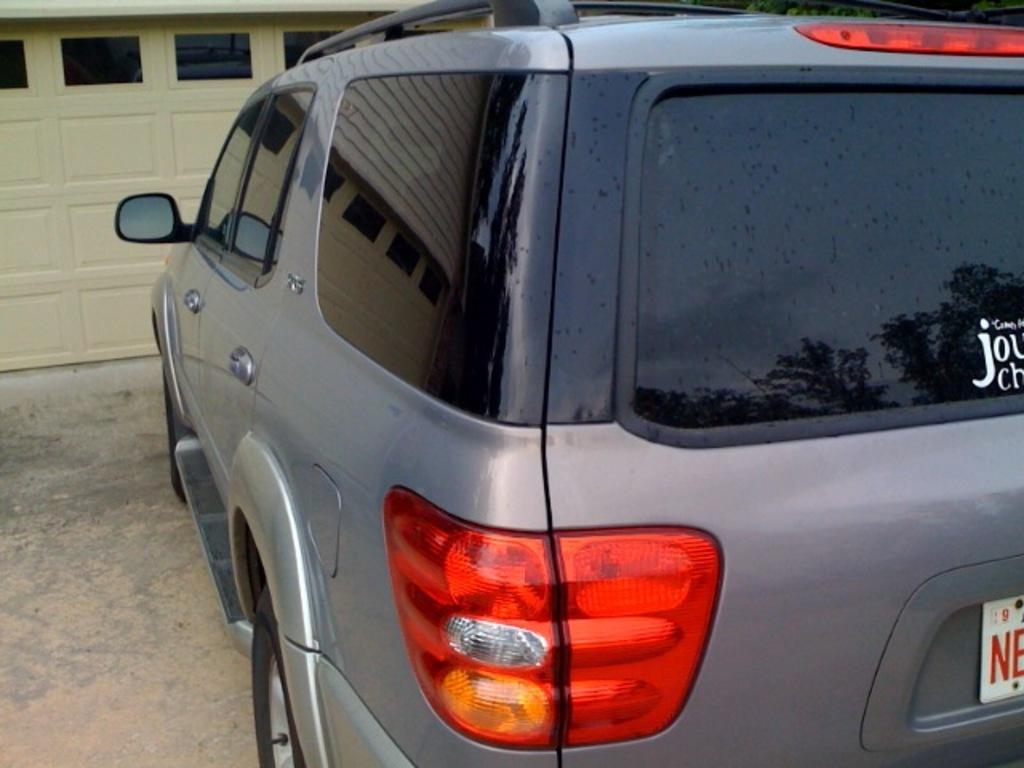What is the main subject of the image? The main subject of the image is a car. Where is the car located in the image? The car is parked on the road. What else can be seen in the image besides the car? There is a building in the image. Reasoning: Let' Let's think step by step in order to produce the conversation. We start by identifying the main subject of the image, which is the car. Then, we describe the car's location, which is on the road. Finally, we mention the presence of a building in the image to provide additional context. Each question is designed to elicit a specific detail about the image that is known from the provided facts. Absurd Question/Answer: What type of sound can be heard coming from the car in the image? There is no sound coming from the car in the image, as it is parked and not running. What type of stocking is hanging from the car in the image? There is no stocking hanging from the car in the image. 